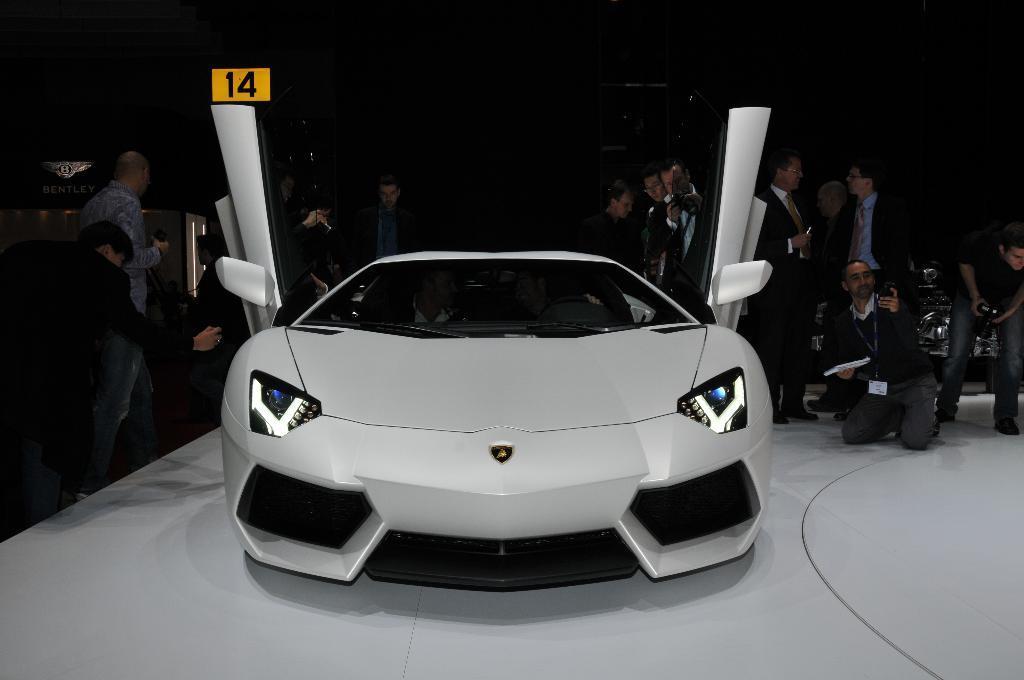Please provide a concise description of this image. In this image I can see few vehicles in different colors. I can see the group people and few people are holding something. The image is dark. 